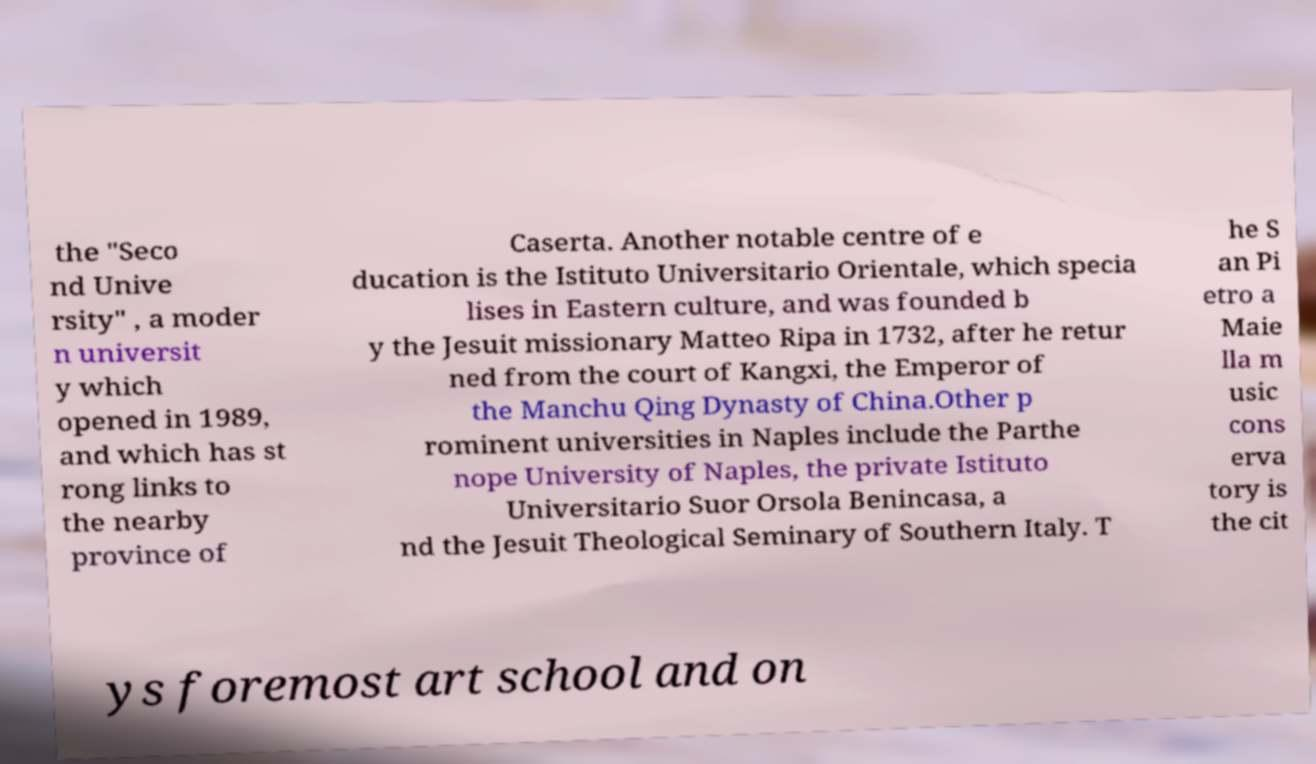For documentation purposes, I need the text within this image transcribed. Could you provide that? the "Seco nd Unive rsity" , a moder n universit y which opened in 1989, and which has st rong links to the nearby province of Caserta. Another notable centre of e ducation is the Istituto Universitario Orientale, which specia lises in Eastern culture, and was founded b y the Jesuit missionary Matteo Ripa in 1732, after he retur ned from the court of Kangxi, the Emperor of the Manchu Qing Dynasty of China.Other p rominent universities in Naples include the Parthe nope University of Naples, the private Istituto Universitario Suor Orsola Benincasa, a nd the Jesuit Theological Seminary of Southern Italy. T he S an Pi etro a Maie lla m usic cons erva tory is the cit ys foremost art school and on 